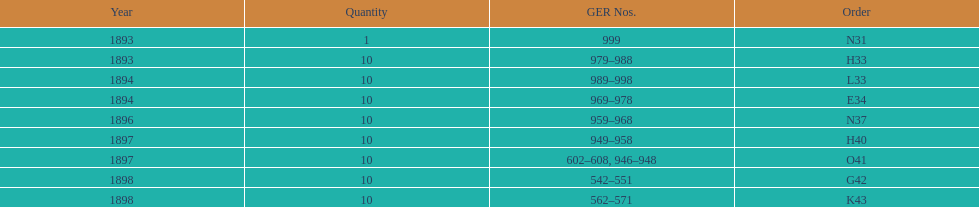How many years are itemized? 5. Would you mind parsing the complete table? {'header': ['Year', 'Quantity', 'GER Nos.', 'Order'], 'rows': [['1893', '1', '999', 'N31'], ['1893', '10', '979–988', 'H33'], ['1894', '10', '989–998', 'L33'], ['1894', '10', '969–978', 'E34'], ['1896', '10', '959–968', 'N37'], ['1897', '10', '949–958', 'H40'], ['1897', '10', '602–608, 946–948', 'O41'], ['1898', '10', '542–551', 'G42'], ['1898', '10', '562–571', 'K43']]} 